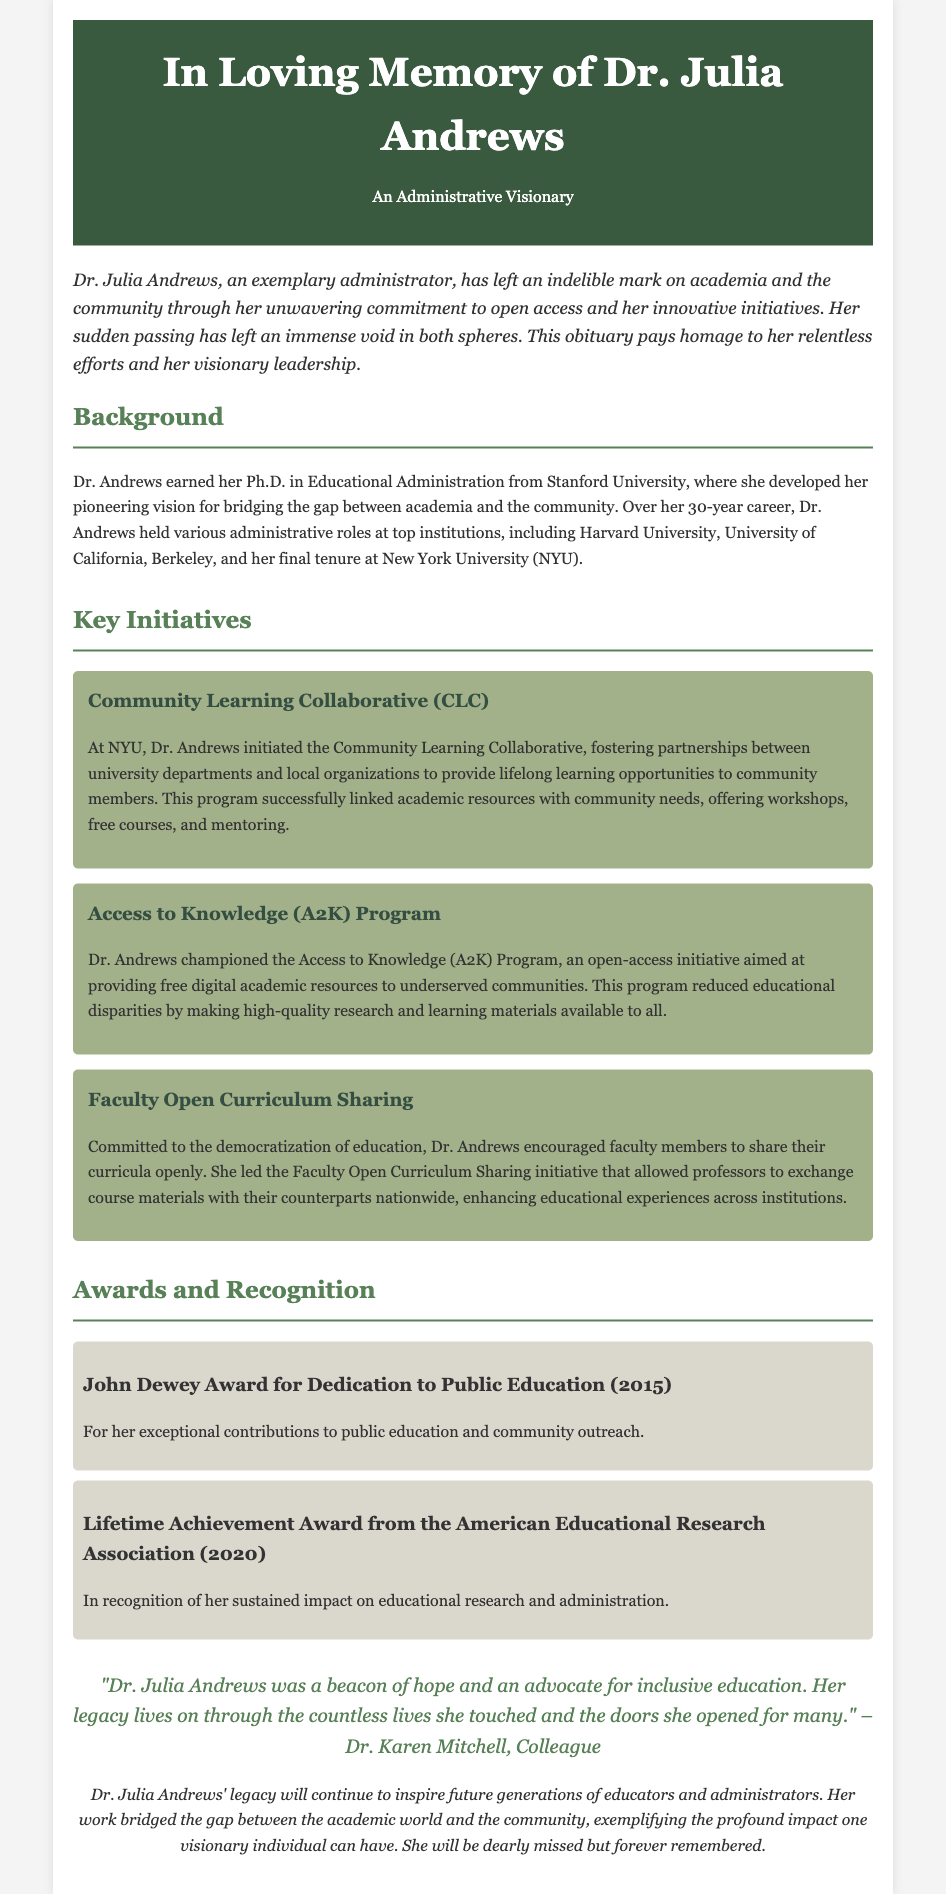What degree did Dr. Andrews earn? The document states that Dr. Andrews earned her Ph.D. in Educational Administration from Stanford University.
Answer: Ph.D. in Educational Administration What initiative aimed at providing free digital academic resources? The document mentions the Access to Knowledge (A2K) Program as an open-access initiative.
Answer: Access to Knowledge (A2K) Program What recognition did Dr. Andrews receive in 2020? The document indicates that she received the Lifetime Achievement Award from the American Educational Research Association in 2020.
Answer: Lifetime Achievement Award from the American Educational Research Association What program did Dr. Andrews create at NYU? The document describes the Community Learning Collaborative initiated by Dr. Andrews at NYU.
Answer: Community Learning Collaborative Who expressed a quote about Dr. Julia Andrews? The document cites Dr. Karen Mitchell as a colleague who expressed a quote about Dr. Andrews.
Answer: Dr. Karen Mitchell How many years did Dr. Andrews spend in her career? The document specifies that Dr. Andrews had a 30-year career in academia.
Answer: 30 years What was one of Dr. Andrews’ key focuses in her initiatives? The document highlights her commitment to open access and community engagement in her initiatives.
Answer: Open access and community engagement What award did she receive in 2015? The document states that she received the John Dewey Award for Dedication to Public Education in 2015.
Answer: John Dewey Award for Dedication to Public Education 